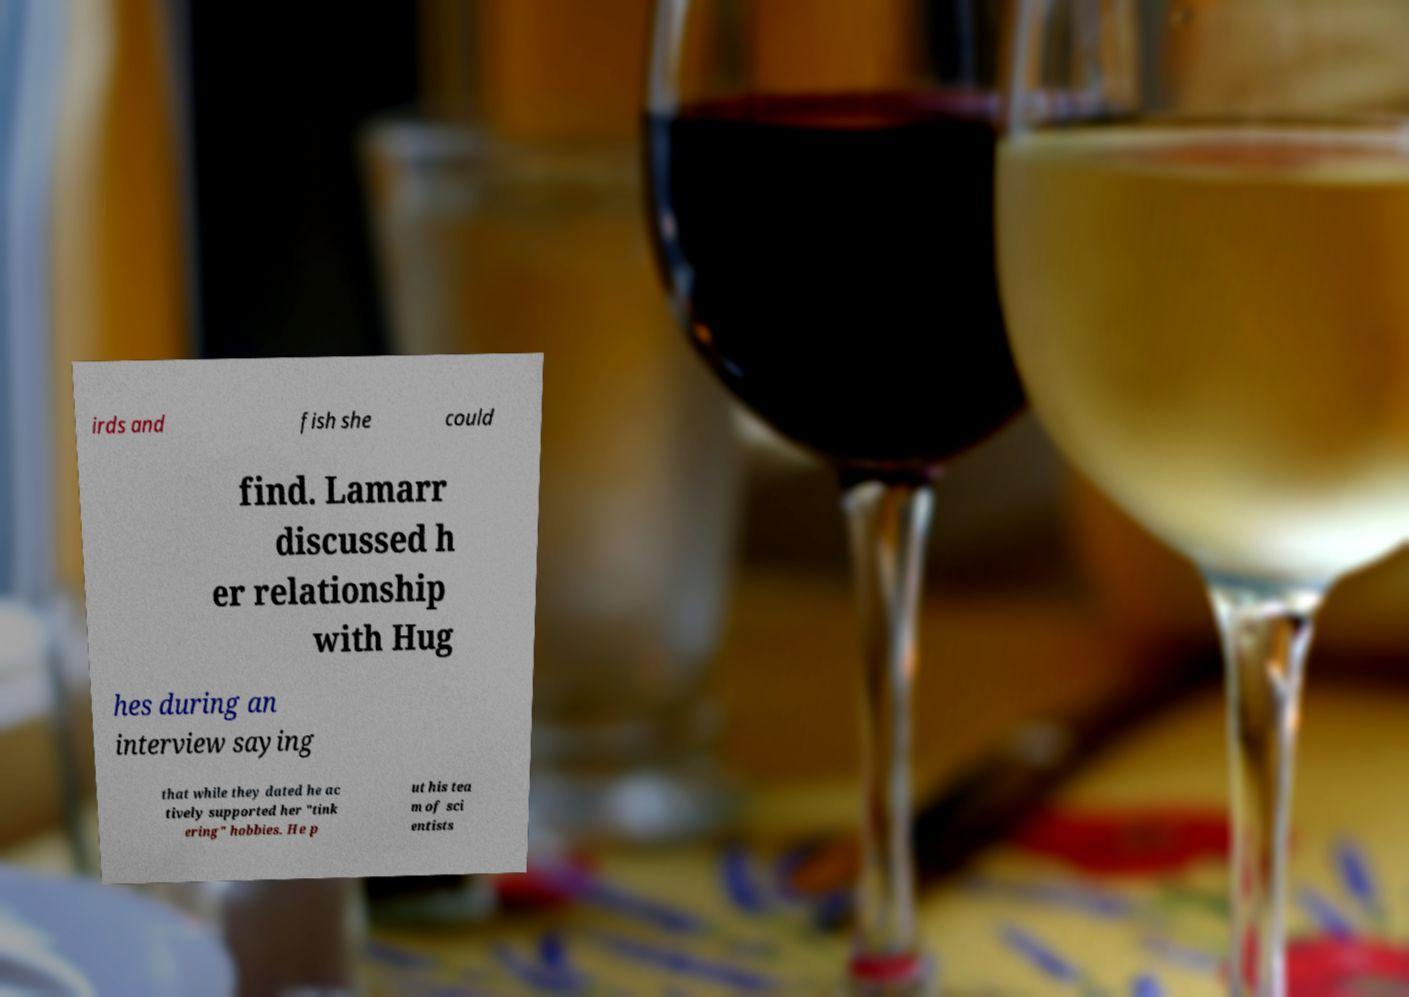Can you accurately transcribe the text from the provided image for me? irds and fish she could find. Lamarr discussed h er relationship with Hug hes during an interview saying that while they dated he ac tively supported her "tink ering" hobbies. He p ut his tea m of sci entists 